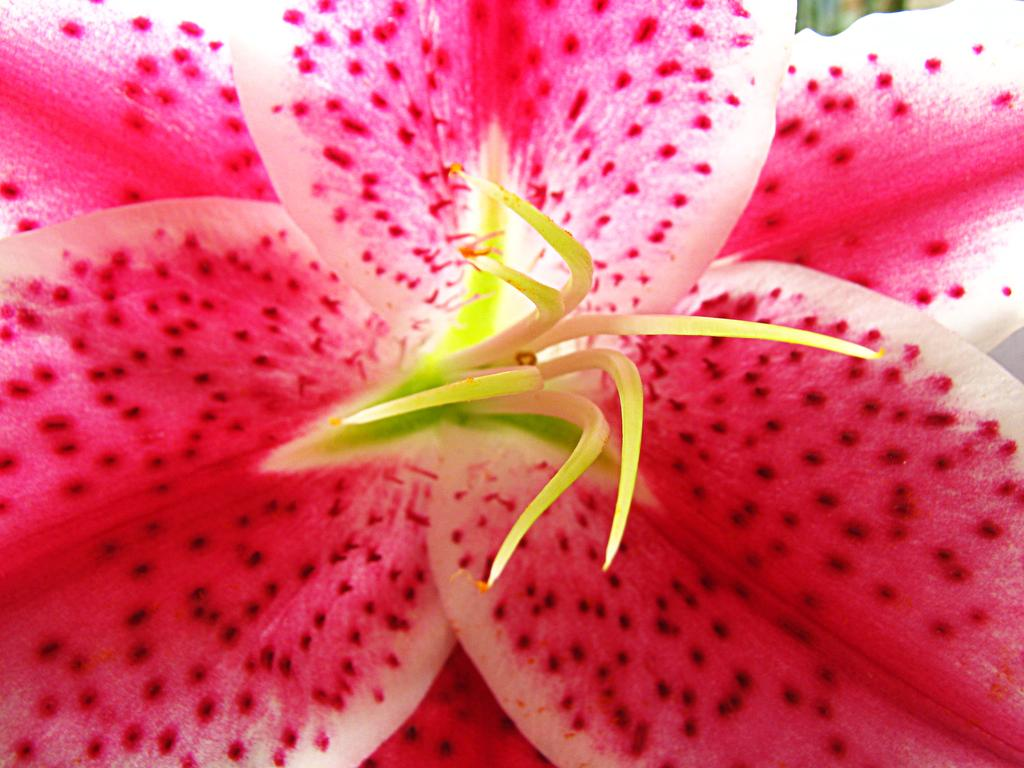What type of flower is present in the image? There is a pink color flower in the image. What is the color of the other object in the image? There is a green color object in the image. What type of match can be seen being played in the image? There is no match or any indication of a game being played in the image. What type of lumber is visible in the image? There is no lumber present in the image. 